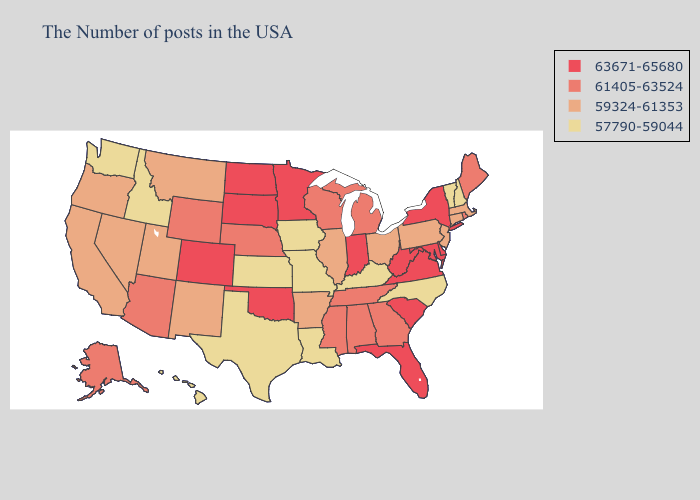Among the states that border Wisconsin , does Michigan have the highest value?
Give a very brief answer. No. Does Maine have the lowest value in the Northeast?
Quick response, please. No. Name the states that have a value in the range 61405-63524?
Write a very short answer. Maine, Rhode Island, Georgia, Michigan, Alabama, Tennessee, Wisconsin, Mississippi, Nebraska, Wyoming, Arizona, Alaska. What is the value of Florida?
Short answer required. 63671-65680. What is the lowest value in the South?
Write a very short answer. 57790-59044. Name the states that have a value in the range 57790-59044?
Keep it brief. New Hampshire, Vermont, North Carolina, Kentucky, Louisiana, Missouri, Iowa, Kansas, Texas, Idaho, Washington, Hawaii. What is the value of Kansas?
Give a very brief answer. 57790-59044. Does Texas have the highest value in the South?
Answer briefly. No. Among the states that border Oklahoma , which have the highest value?
Quick response, please. Colorado. Which states have the lowest value in the USA?
Keep it brief. New Hampshire, Vermont, North Carolina, Kentucky, Louisiana, Missouri, Iowa, Kansas, Texas, Idaho, Washington, Hawaii. Among the states that border Massachusetts , does New York have the highest value?
Write a very short answer. Yes. What is the value of Alaska?
Give a very brief answer. 61405-63524. What is the highest value in the Northeast ?
Be succinct. 63671-65680. Name the states that have a value in the range 59324-61353?
Short answer required. Massachusetts, Connecticut, New Jersey, Pennsylvania, Ohio, Illinois, Arkansas, New Mexico, Utah, Montana, Nevada, California, Oregon. What is the value of Nevada?
Concise answer only. 59324-61353. 